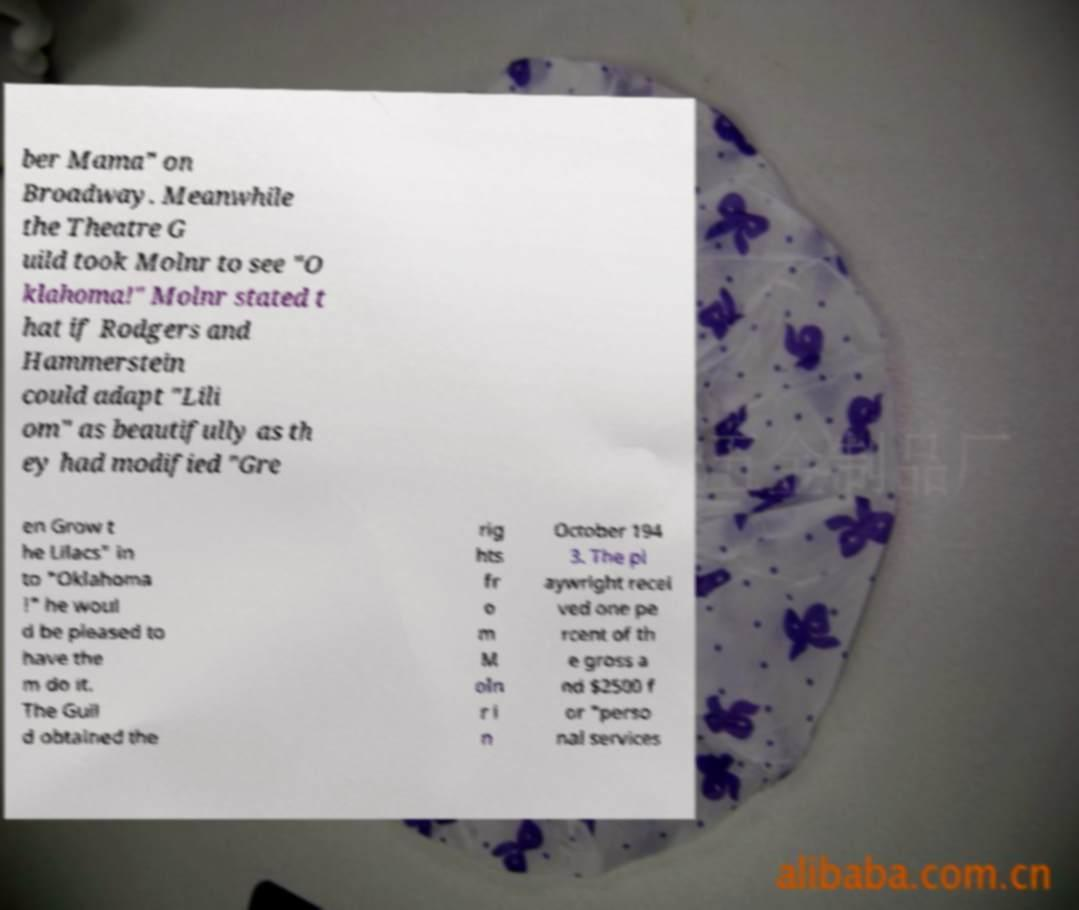Could you assist in decoding the text presented in this image and type it out clearly? ber Mama" on Broadway. Meanwhile the Theatre G uild took Molnr to see "O klahoma!" Molnr stated t hat if Rodgers and Hammerstein could adapt "Lili om" as beautifully as th ey had modified "Gre en Grow t he Lilacs" in to "Oklahoma !" he woul d be pleased to have the m do it. The Guil d obtained the rig hts fr o m M oln r i n October 194 3. The pl aywright recei ved one pe rcent of th e gross a nd $2500 f or "perso nal services 